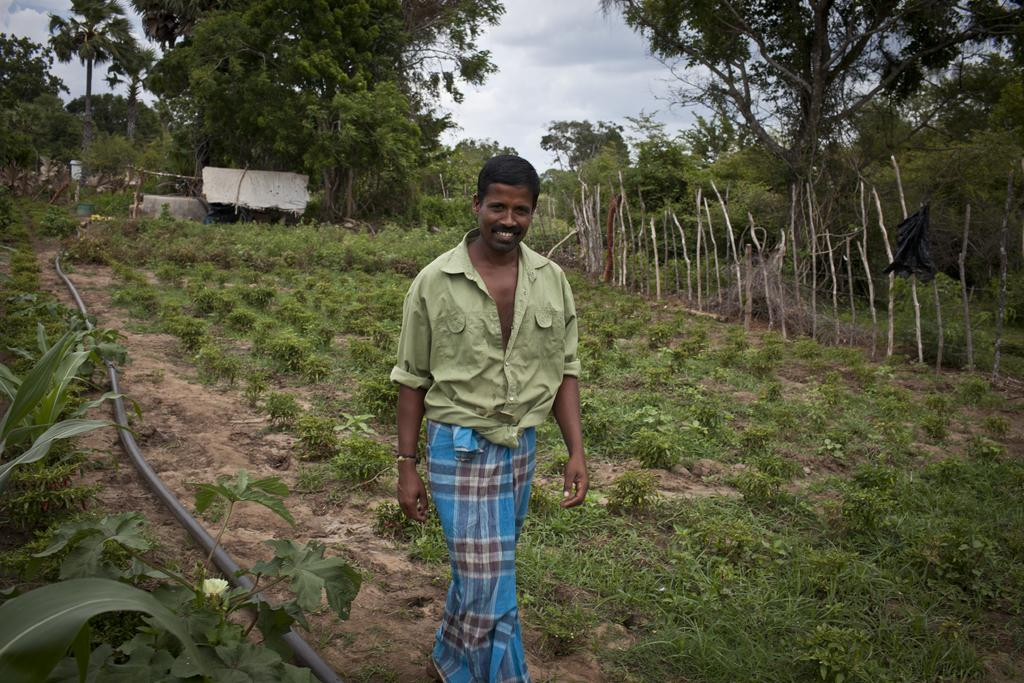Who is present in the image? There is a man in the image. What is the man doing in the image? The man is walking on a grass surface. What else can be seen on the grass surface? There is a pipe on the grass surface. What is visible in the background of the image? Trees and the sky are visible in the background of the image. What can be observed in the sky? Clouds are present in the sky. What type of bed can be seen in the image? There is no bed present in the image; it features a man walking on a grass surface with a pipe nearby and trees and clouds in the background. What experience does the man have while walking in the image? The image does not provide information about the man's experience while walking; it only shows him walking on a grass surface with a pipe nearby and trees and clouds in the background. 